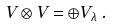<formula> <loc_0><loc_0><loc_500><loc_500>V \otimes V = \oplus V _ { \lambda } \, .</formula> 